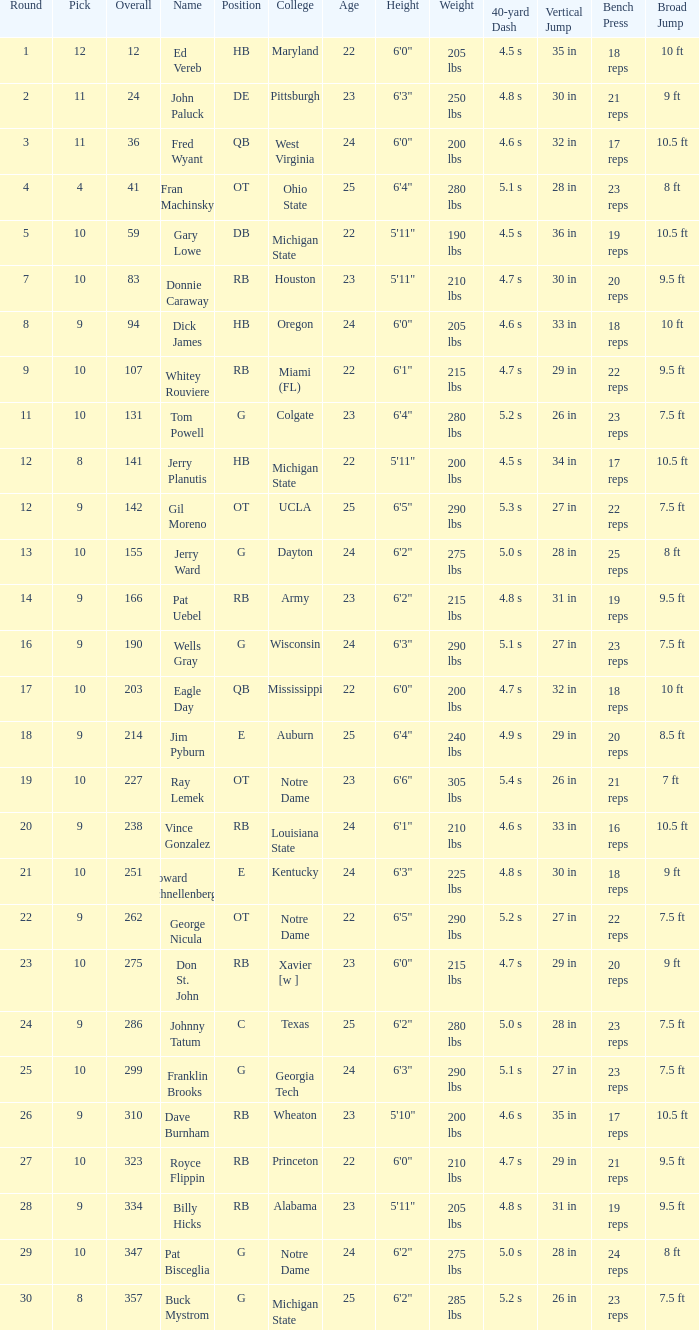What is the total number of overall picks that were after pick 9 and went to Auburn College? 0.0. 